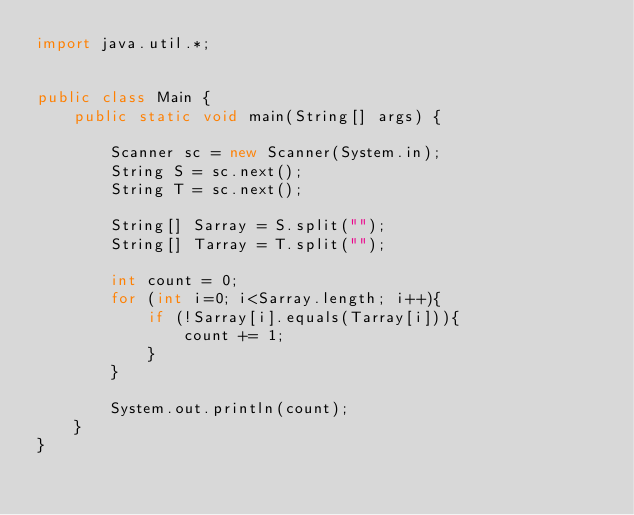<code> <loc_0><loc_0><loc_500><loc_500><_Java_>import java.util.*;


public class Main {
    public static void main(String[] args) {

        Scanner sc = new Scanner(System.in);
        String S = sc.next();
		String T = sc.next();
      
      	String[] Sarray = S.split("");
      	String[] Tarray = T.split("");
      
      	int count = 0;
      	for (int i=0; i<Sarray.length; i++){
          	if (!Sarray[i].equals(Tarray[i])){
              	count += 1;
            }
        }
        
        System.out.println(count);
    }
}</code> 